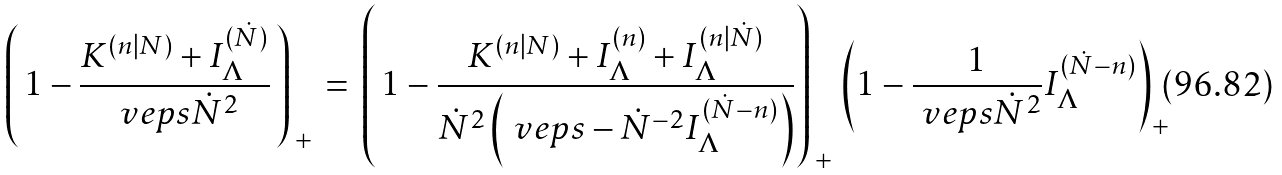Convert formula to latex. <formula><loc_0><loc_0><loc_500><loc_500>\left ( \, 1 - \frac { K ^ { ( n | N ) } + I _ { \Lambda } ^ { ( \dot { N } ) } } { \ v e p s { \dot { N } } ^ { 2 } } \, \right ) _ { \, + } \, = \, \left ( \, 1 - \frac { K ^ { ( n | N ) } + I _ { \Lambda } ^ { ( n ) } + I _ { \Lambda } ^ { ( n | \dot { N } ) } } { { \dot { N } } ^ { 2 } \left ( \ v e p s - { \dot { N } } ^ { - 2 } I _ { \Lambda } ^ { ( \dot { N } - n ) } \right ) } \right ) _ { \, + } \, \left ( 1 - { \frac { 1 } { \ v e p s { \dot { N } } ^ { 2 } } } I _ { \Lambda } ^ { ( \dot { N } - n ) } \right ) _ { + }</formula> 